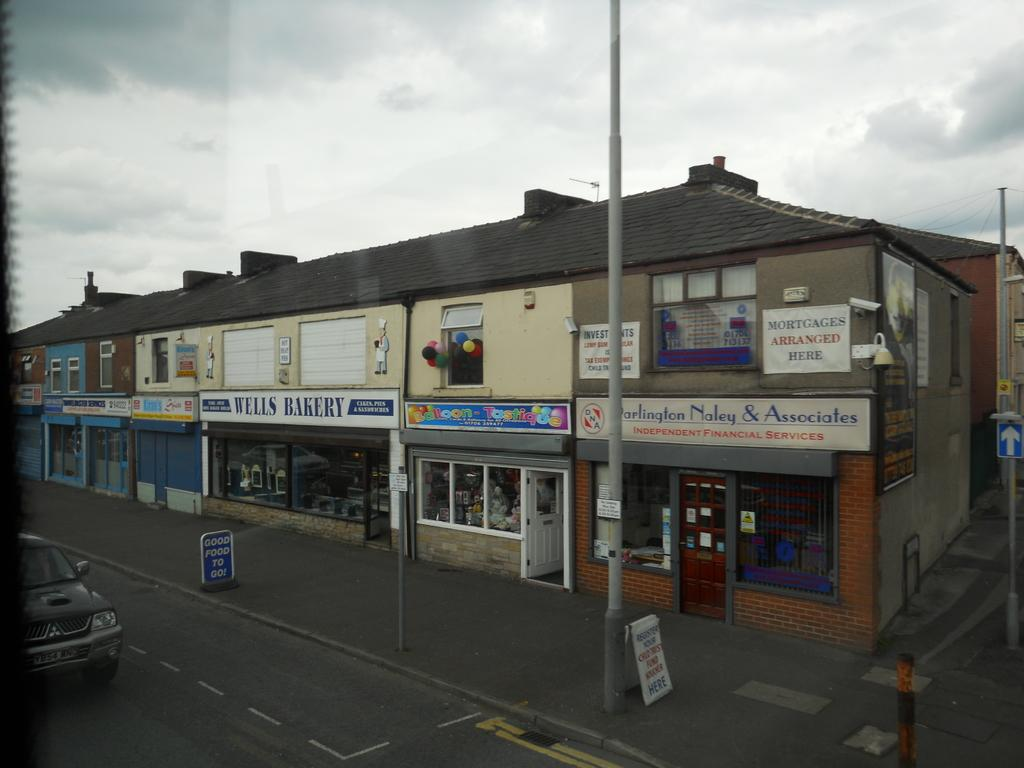What type of structures can be seen in the image? There are buildings in the image. What other objects can be seen in the image besides buildings? There are boards, poles, doors, and a vehicle on the road visible in the image. What is visible in the background of the image? There is sky visible in the background of the image, with clouds present. Reasoning: Let' Let's think step by step in order to produce the conversation. We start by identifying the main subject of the image, which is the buildings. Then, we expand the conversation to include other objects that are also visible, such as boards, poles, doors, and the vehicle on the road. We also mention the sky and clouds visible in the background. Each question is designed to elicit a specific detail about the image that is known from the provided facts. Absurd Question/Answer: What type of quartz can be seen in the image? There is no quartz present in the image. How does the anger of the people in the image affect the buildings? There are no people or indication of anger in the image, so it cannot be determined how it would affect the buildings. 